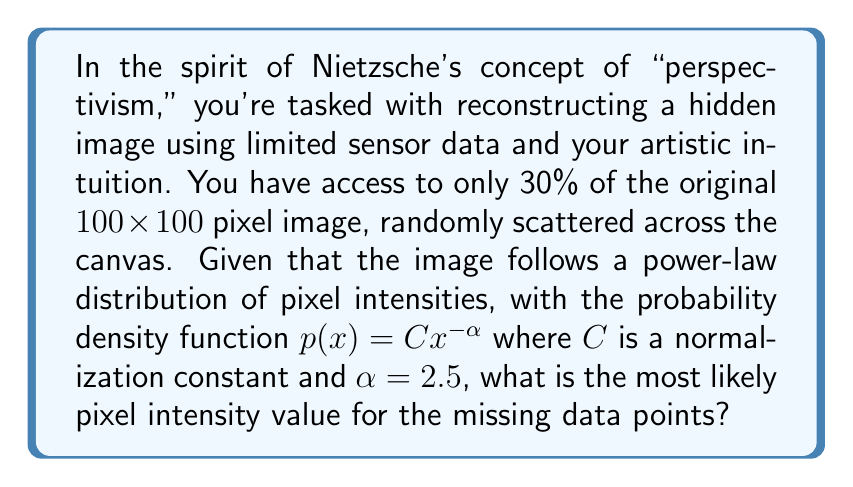Can you solve this math problem? To solve this problem, we'll follow these steps:

1) In a power-law distribution, the most likely value (mode) occurs at the lower bound of the distribution. For pixel intensities, this lower bound is typically 0, but since we're dealing with visible pixels, we'll assume a lower bound of 1.

2) The probability density function is given by:

   $$p(x) = Cx^{-\alpha}$$

   where $C$ is a normalization constant and $\alpha = 2.5$.

3) To find the normalization constant $C$, we integrate the PDF over the range of possible pixel values (1 to 255 for an 8-bit image) and set it equal to 1:

   $$\int_1^{255} Cx^{-2.5} dx = 1$$

4) Solving this integral:

   $$C \left[-\frac{x^{-1.5}}{1.5}\right]_1^{255} = 1$$
   
   $$C \left(-\frac{255^{-1.5}}{1.5} + \frac{1}{1.5}\right) = 1$$

5) Solving for $C$:

   $$C \approx 1.6329$$

6) Now that we have $C$, we can write the full PDF:

   $$p(x) = 1.6329x^{-2.5}$$

7) The mode of this distribution (the most likely value) occurs at the lower bound, which is 1.

Therefore, the most likely pixel intensity for the missing data points is 1, which corresponds to the darkest visible pixel.

This approach aligns with Nietzsche's perspectivism by acknowledging that our limited "perspective" (the 30% of known pixels) informs our reconstruction of the whole, while also recognizing the underlying structure (power-law distribution) that shapes the image.
Answer: 1 